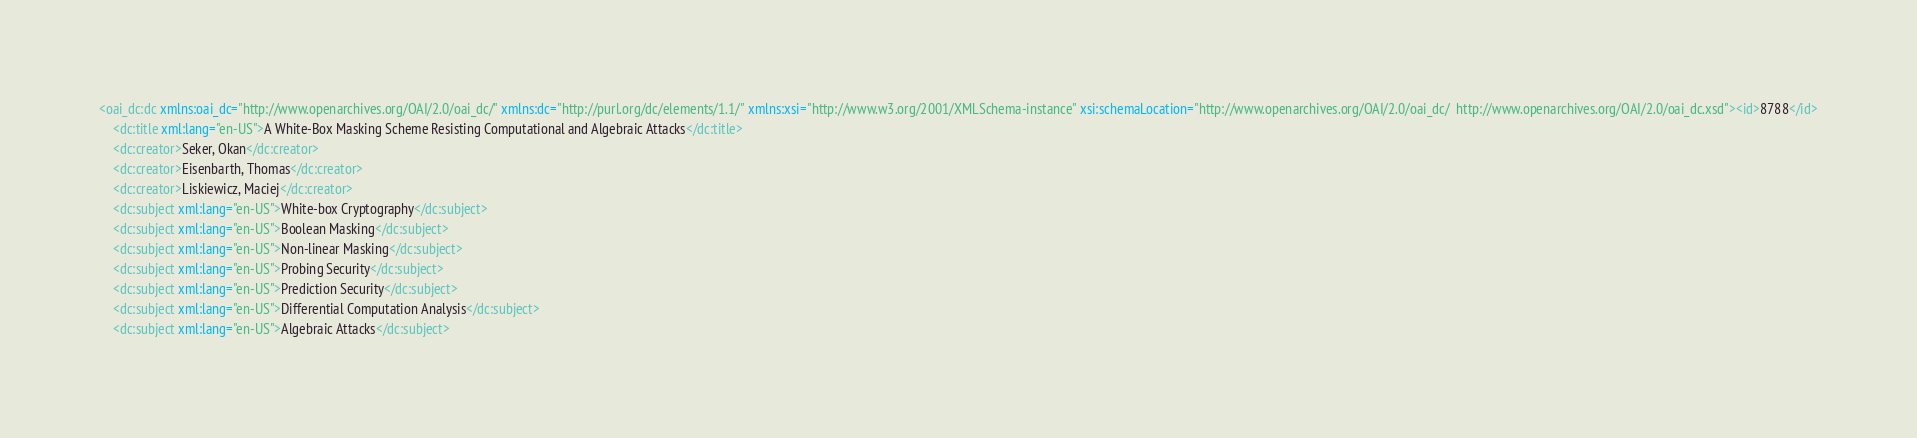Convert code to text. <code><loc_0><loc_0><loc_500><loc_500><_XML_><oai_dc:dc xmlns:oai_dc="http://www.openarchives.org/OAI/2.0/oai_dc/" xmlns:dc="http://purl.org/dc/elements/1.1/" xmlns:xsi="http://www.w3.org/2001/XMLSchema-instance" xsi:schemaLocation="http://www.openarchives.org/OAI/2.0/oai_dc/  http://www.openarchives.org/OAI/2.0/oai_dc.xsd"><id>8788</id>
	<dc:title xml:lang="en-US">A White-Box Masking Scheme Resisting Computational and Algebraic Attacks</dc:title>
	<dc:creator>Seker, Okan</dc:creator>
	<dc:creator>Eisenbarth, Thomas</dc:creator>
	<dc:creator>Liskiewicz, Maciej</dc:creator>
	<dc:subject xml:lang="en-US">White-box Cryptography</dc:subject>
	<dc:subject xml:lang="en-US">Boolean Masking</dc:subject>
	<dc:subject xml:lang="en-US">Non-linear Masking</dc:subject>
	<dc:subject xml:lang="en-US">Probing Security</dc:subject>
	<dc:subject xml:lang="en-US">Prediction Security</dc:subject>
	<dc:subject xml:lang="en-US">Differential Computation Analysis</dc:subject>
	<dc:subject xml:lang="en-US">Algebraic Attacks</dc:subject></code> 